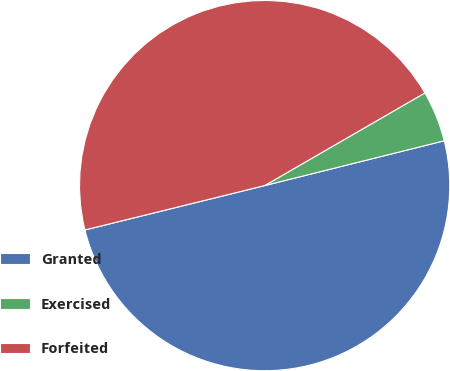<chart> <loc_0><loc_0><loc_500><loc_500><pie_chart><fcel>Granted<fcel>Exercised<fcel>Forfeited<nl><fcel>50.04%<fcel>4.45%<fcel>45.51%<nl></chart> 